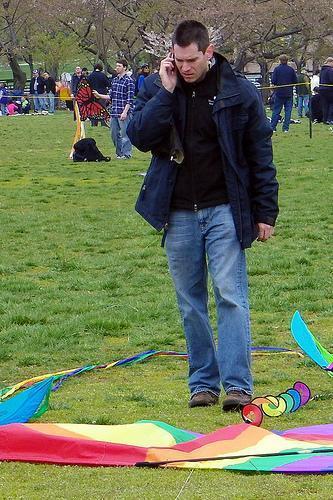How many people on the phone?
Give a very brief answer. 1. 